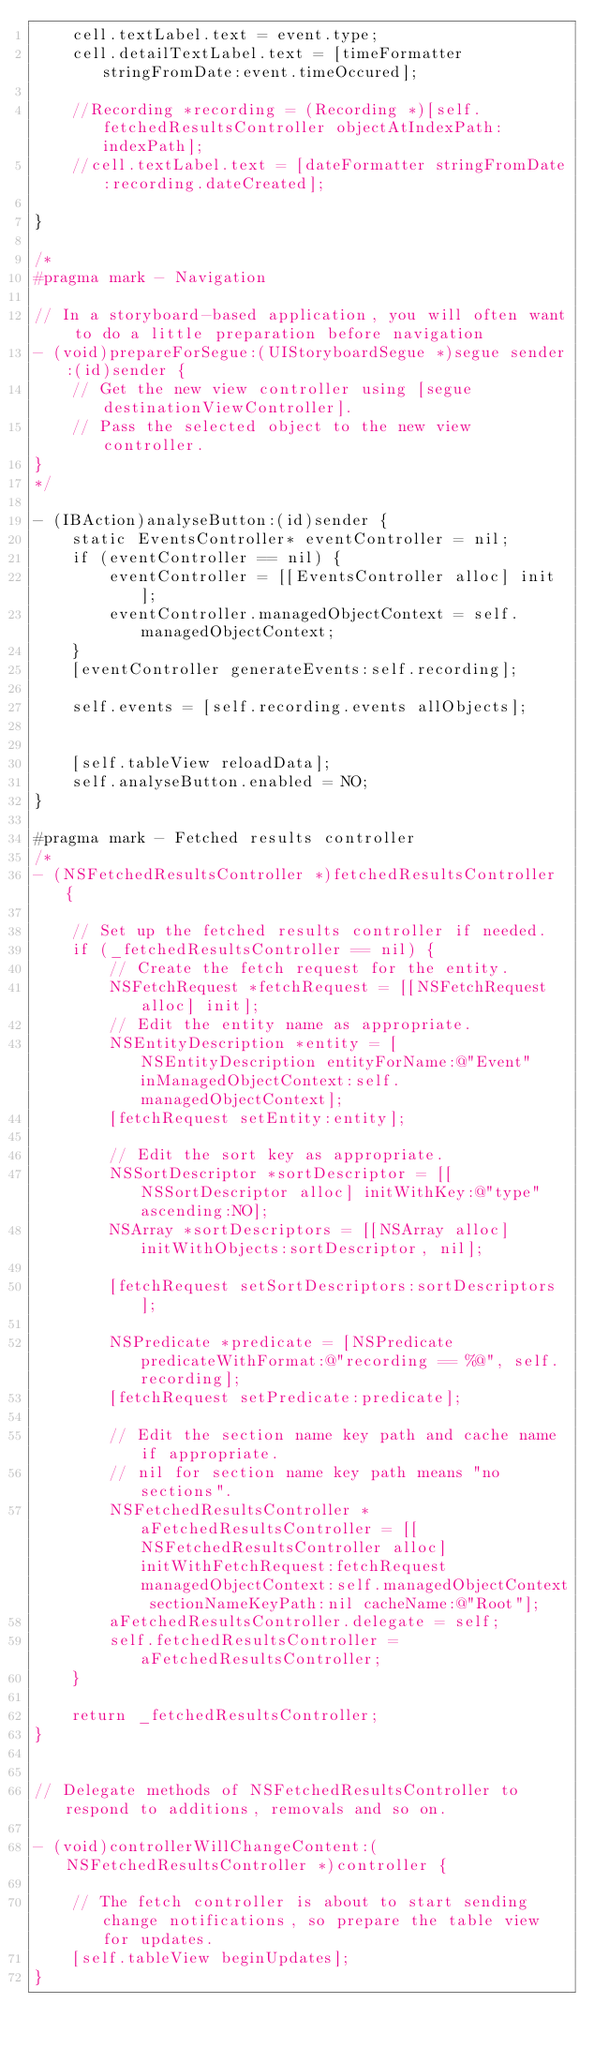Convert code to text. <code><loc_0><loc_0><loc_500><loc_500><_ObjectiveC_>    cell.textLabel.text = event.type;
    cell.detailTextLabel.text = [timeFormatter stringFromDate:event.timeOccured];
    
    //Recording *recording = (Recording *)[self.fetchedResultsController objectAtIndexPath:indexPath];
    //cell.textLabel.text = [dateFormatter stringFromDate:recording.dateCreated];
    
}

/*
#pragma mark - Navigation

// In a storyboard-based application, you will often want to do a little preparation before navigation
- (void)prepareForSegue:(UIStoryboardSegue *)segue sender:(id)sender {
    // Get the new view controller using [segue destinationViewController].
    // Pass the selected object to the new view controller.
}
*/

- (IBAction)analyseButton:(id)sender {
    static EventsController* eventController = nil;
    if (eventController == nil) {
        eventController = [[EventsController alloc] init];
        eventController.managedObjectContext = self.managedObjectContext;
    }
    [eventController generateEvents:self.recording];
    
    self.events = [self.recording.events allObjects];

    
    [self.tableView reloadData];
    self.analyseButton.enabled = NO;
}

#pragma mark - Fetched results controller
/*
- (NSFetchedResultsController *)fetchedResultsController {
    
    // Set up the fetched results controller if needed.
    if (_fetchedResultsController == nil) {
        // Create the fetch request for the entity.
        NSFetchRequest *fetchRequest = [[NSFetchRequest alloc] init];
        // Edit the entity name as appropriate.
        NSEntityDescription *entity = [NSEntityDescription entityForName:@"Event" inManagedObjectContext:self.managedObjectContext];
        [fetchRequest setEntity:entity];
        
        // Edit the sort key as appropriate.
        NSSortDescriptor *sortDescriptor = [[NSSortDescriptor alloc] initWithKey:@"type" ascending:NO];
        NSArray *sortDescriptors = [[NSArray alloc] initWithObjects:sortDescriptor, nil];
        
        [fetchRequest setSortDescriptors:sortDescriptors];
        
        NSPredicate *predicate = [NSPredicate predicateWithFormat:@"recording == %@", self.recording];
        [fetchRequest setPredicate:predicate];
        
        // Edit the section name key path and cache name if appropriate.
        // nil for section name key path means "no sections".
        NSFetchedResultsController *aFetchedResultsController = [[NSFetchedResultsController alloc] initWithFetchRequest:fetchRequest managedObjectContext:self.managedObjectContext sectionNameKeyPath:nil cacheName:@"Root"];
        aFetchedResultsController.delegate = self;
        self.fetchedResultsController = aFetchedResultsController;
    }
    
    return _fetchedResultsController;
}


// Delegate methods of NSFetchedResultsController to respond to additions, removals and so on.
 
- (void)controllerWillChangeContent:(NSFetchedResultsController *)controller {
    
    // The fetch controller is about to start sending change notifications, so prepare the table view for updates.
    [self.tableView beginUpdates];
}
</code> 